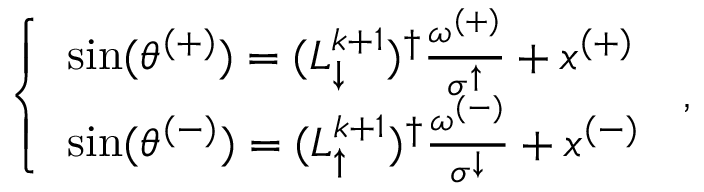Convert formula to latex. <formula><loc_0><loc_0><loc_500><loc_500>\begin{array} { r } { \left \{ \begin{array} { l l } { \sin ( \theta ^ { ( + ) } ) = ( L _ { \downarrow } ^ { k + 1 } ) ^ { \dagger } \frac { \omega ^ { ( + ) } } { \sigma ^ { \uparrow } } + x ^ { ( + ) } } \\ { \sin ( \theta ^ { ( - ) } ) = ( L _ { \uparrow } ^ { k + 1 } ) ^ { \dagger } \frac { \omega ^ { ( - ) } } { \sigma ^ { \downarrow } } + x ^ { ( - ) } } \end{array} \, , } \end{array}</formula> 